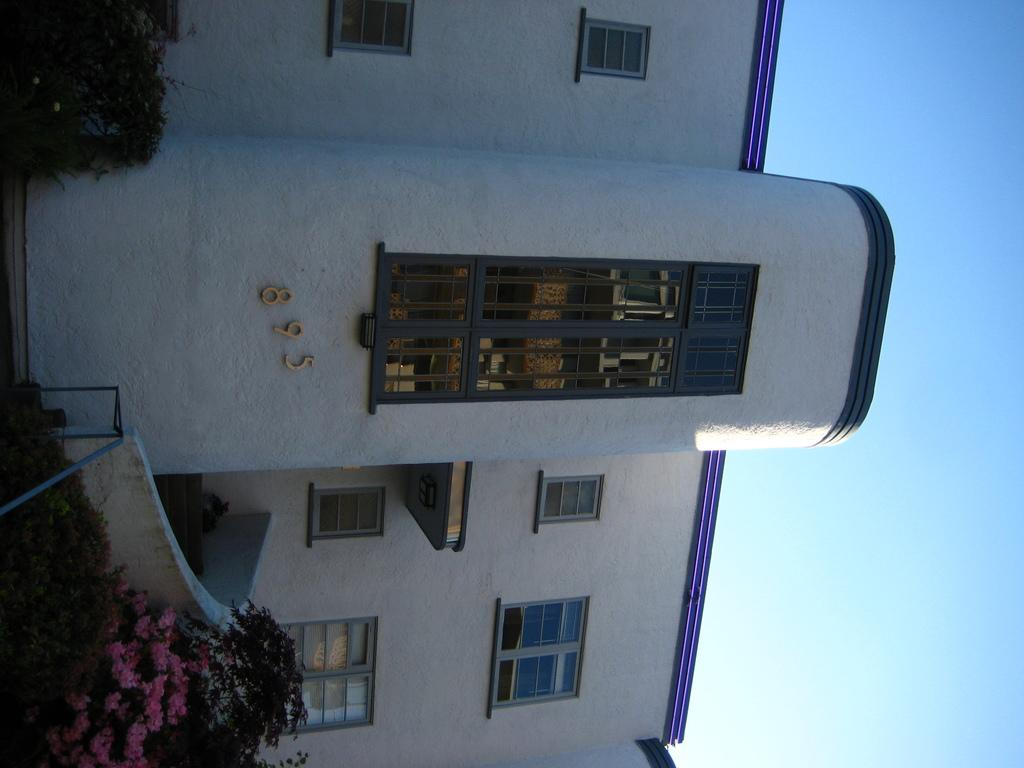What structure is the main subject of the image? There is a building in the image. What can be seen on the wall of the building? There are numbers written on the wall of the building. What type of vegetation is present in front of the building? There are plants in front of the building. What type of flowers can be seen in front of the building? There are flowers in front of the building. What message of peace can be seen in the image? There is no message of peace present in the image; it only features a building with numbers on the wall and plants and flowers in front. 